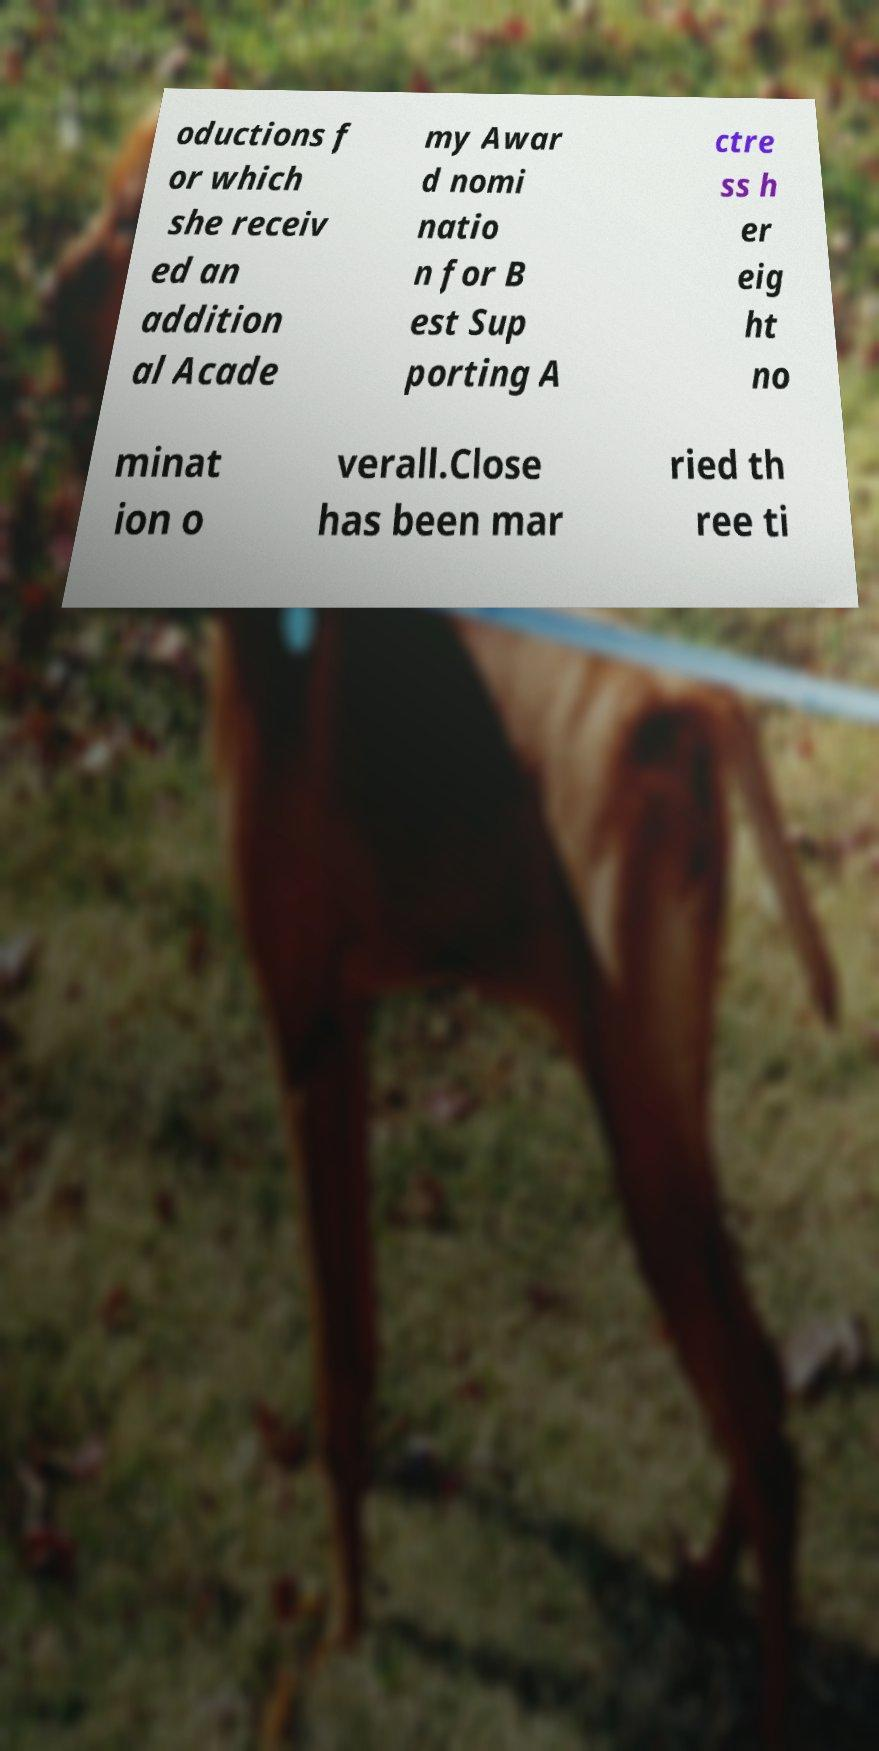Can you accurately transcribe the text from the provided image for me? oductions f or which she receiv ed an addition al Acade my Awar d nomi natio n for B est Sup porting A ctre ss h er eig ht no minat ion o verall.Close has been mar ried th ree ti 